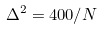Convert formula to latex. <formula><loc_0><loc_0><loc_500><loc_500>\Delta ^ { 2 } = 4 0 0 / N</formula> 